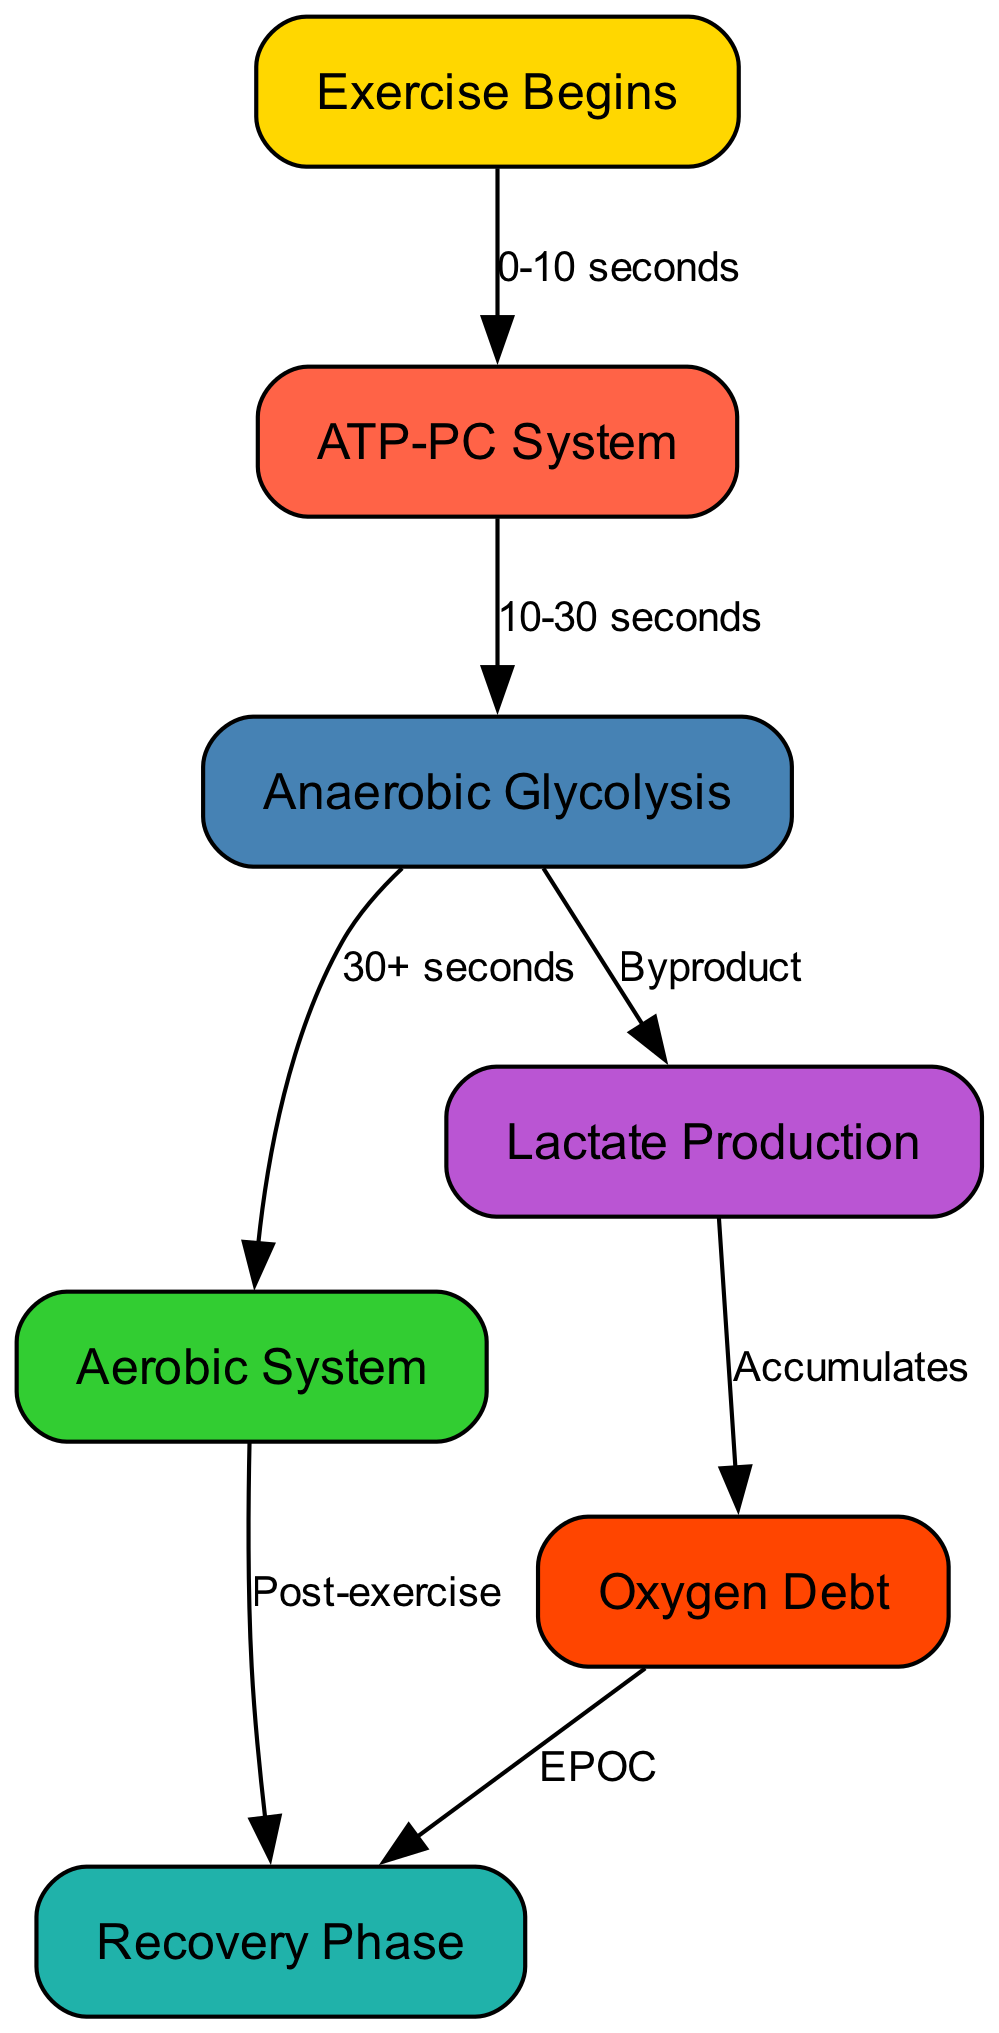What is the first system activated during exercise? The diagram shows that the first node reached after "Exercise Begins" is "ATP-PC System," indicating that it is activated almost immediately.
Answer: ATP-PC System How long does the ATP-PC system last? According to the diagram, the ATP-PC system operates from "0-10 seconds" after exercise begins, providing a specific timeframe for its activation.
Answer: 10 seconds What follows anaerobic glycolysis in the energy flow? The adenine follows the arrow leading from "Anaerobic Glycolysis" to "Aerobic System," signifying that after glycolysis, the body transitions to aerobic metabolism.
Answer: Aerobic System What byproduct is produced during glycolysis? The diagram indicates that a flow is directed to "Lactate Production," showing that lactate is produced as a byproduct of anaerobic glycolysis.
Answer: Lactate Production How does lactate relate to oxygen debt? The flow from "Lactate Production" to "Oxygen Debt" shows that lactate accumulates and contributes to the oxygen debt experienced during exercise.
Answer: Accumulates What occurs in the recovery phase after aerobic metabolism? The connection from the "Aerobic System" to "Recovery Phase" indicates that recovery follows aerobic metabolism post-exercise, highlighting the focus on rebuilding and replenishing energy stores.
Answer: Recovery Phase How is oxygen debt related to recovery? The diagram illustrates that oxygen debt directly leads to the recovery phase, signifying that resolving oxygen debt is part of the recovery process after strenuous activity.
Answer: EPOC What color represents the ATP-PC system in the diagram? Referring to the color legend in the diagram, the ATP-PC System is illustrated in tomato red, which is consistent across the visual representation for clarity.
Answer: Tomato How many nodes are there in the diagram? Counting the distinct nodes present in the diagram, including all the identified energy systems and processes, presents a total of seven nodes.
Answer: Seven nodes 